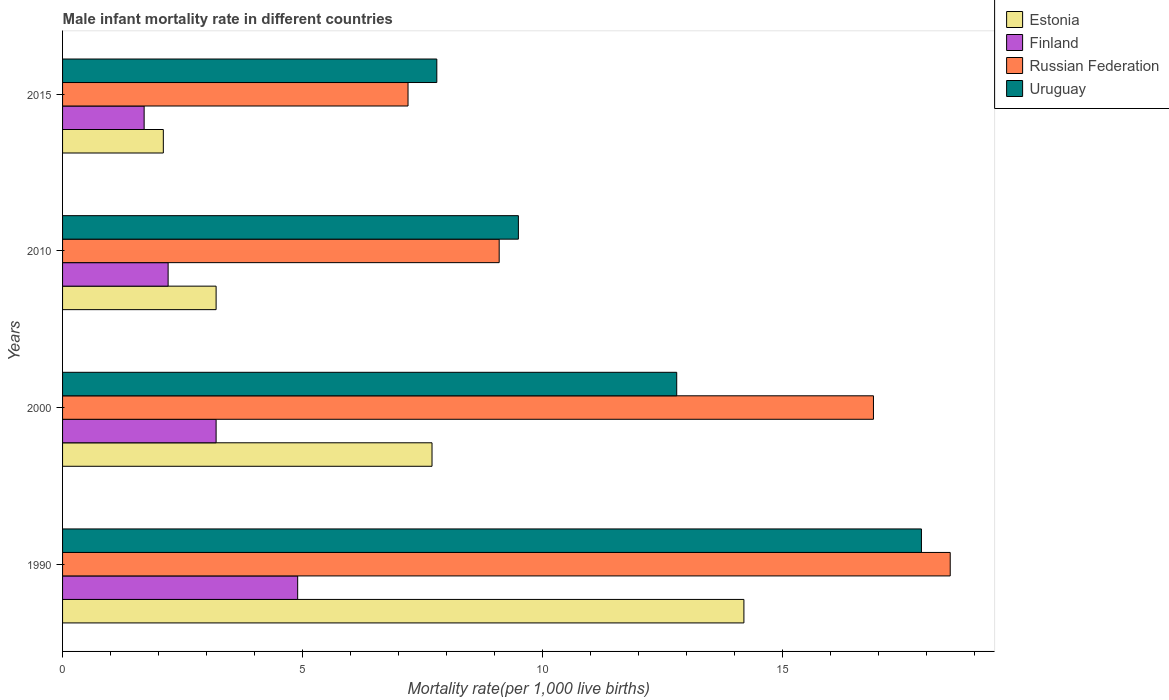How many bars are there on the 2nd tick from the top?
Offer a terse response. 4. What is the label of the 3rd group of bars from the top?
Make the answer very short. 2000. In which year was the male infant mortality rate in Russian Federation maximum?
Keep it short and to the point. 1990. In which year was the male infant mortality rate in Finland minimum?
Ensure brevity in your answer.  2015. What is the total male infant mortality rate in Estonia in the graph?
Your answer should be very brief. 27.2. What is the difference between the male infant mortality rate in Finland in 2010 and that in 2015?
Ensure brevity in your answer.  0.5. What is the difference between the male infant mortality rate in Finland in 1990 and the male infant mortality rate in Uruguay in 2010?
Give a very brief answer. -4.6. In the year 2000, what is the difference between the male infant mortality rate in Uruguay and male infant mortality rate in Russian Federation?
Ensure brevity in your answer.  -4.1. In how many years, is the male infant mortality rate in Uruguay greater than 16 ?
Give a very brief answer. 1. What is the ratio of the male infant mortality rate in Uruguay in 1990 to that in 2010?
Provide a short and direct response. 1.88. Is the male infant mortality rate in Estonia in 1990 less than that in 2015?
Your response must be concise. No. What is the difference between the highest and the second highest male infant mortality rate in Estonia?
Your response must be concise. 6.5. What is the difference between the highest and the lowest male infant mortality rate in Uruguay?
Give a very brief answer. 10.1. Is it the case that in every year, the sum of the male infant mortality rate in Finland and male infant mortality rate in Uruguay is greater than the sum of male infant mortality rate in Russian Federation and male infant mortality rate in Estonia?
Your answer should be very brief. No. What does the 3rd bar from the top in 2015 represents?
Your answer should be very brief. Finland. What does the 4th bar from the bottom in 2015 represents?
Make the answer very short. Uruguay. Is it the case that in every year, the sum of the male infant mortality rate in Finland and male infant mortality rate in Estonia is greater than the male infant mortality rate in Russian Federation?
Provide a short and direct response. No. How many legend labels are there?
Make the answer very short. 4. What is the title of the graph?
Give a very brief answer. Male infant mortality rate in different countries. Does "Ethiopia" appear as one of the legend labels in the graph?
Your answer should be compact. No. What is the label or title of the X-axis?
Your response must be concise. Mortality rate(per 1,0 live births). What is the Mortality rate(per 1,000 live births) of Estonia in 1990?
Give a very brief answer. 14.2. What is the Mortality rate(per 1,000 live births) of Uruguay in 1990?
Your answer should be compact. 17.9. What is the Mortality rate(per 1,000 live births) in Estonia in 2000?
Your response must be concise. 7.7. What is the Mortality rate(per 1,000 live births) in Estonia in 2010?
Keep it short and to the point. 3.2. What is the Mortality rate(per 1,000 live births) of Finland in 2010?
Ensure brevity in your answer.  2.2. What is the Mortality rate(per 1,000 live births) in Uruguay in 2010?
Keep it short and to the point. 9.5. What is the Mortality rate(per 1,000 live births) of Finland in 2015?
Keep it short and to the point. 1.7. What is the Mortality rate(per 1,000 live births) of Russian Federation in 2015?
Offer a terse response. 7.2. What is the Mortality rate(per 1,000 live births) in Uruguay in 2015?
Provide a short and direct response. 7.8. Across all years, what is the maximum Mortality rate(per 1,000 live births) of Finland?
Your response must be concise. 4.9. Across all years, what is the minimum Mortality rate(per 1,000 live births) in Finland?
Provide a short and direct response. 1.7. Across all years, what is the minimum Mortality rate(per 1,000 live births) in Russian Federation?
Offer a terse response. 7.2. What is the total Mortality rate(per 1,000 live births) of Estonia in the graph?
Offer a terse response. 27.2. What is the total Mortality rate(per 1,000 live births) of Finland in the graph?
Keep it short and to the point. 12. What is the total Mortality rate(per 1,000 live births) of Russian Federation in the graph?
Give a very brief answer. 51.7. What is the difference between the Mortality rate(per 1,000 live births) of Finland in 1990 and that in 2000?
Give a very brief answer. 1.7. What is the difference between the Mortality rate(per 1,000 live births) of Russian Federation in 1990 and that in 2000?
Give a very brief answer. 1.6. What is the difference between the Mortality rate(per 1,000 live births) of Uruguay in 1990 and that in 2010?
Offer a very short reply. 8.4. What is the difference between the Mortality rate(per 1,000 live births) of Estonia in 1990 and that in 2015?
Keep it short and to the point. 12.1. What is the difference between the Mortality rate(per 1,000 live births) in Uruguay in 1990 and that in 2015?
Your answer should be very brief. 10.1. What is the difference between the Mortality rate(per 1,000 live births) in Estonia in 2000 and that in 2010?
Make the answer very short. 4.5. What is the difference between the Mortality rate(per 1,000 live births) in Finland in 2000 and that in 2010?
Provide a succinct answer. 1. What is the difference between the Mortality rate(per 1,000 live births) of Finland in 2000 and that in 2015?
Provide a short and direct response. 1.5. What is the difference between the Mortality rate(per 1,000 live births) of Uruguay in 2000 and that in 2015?
Your answer should be very brief. 5. What is the difference between the Mortality rate(per 1,000 live births) in Estonia in 1990 and the Mortality rate(per 1,000 live births) in Finland in 2000?
Offer a very short reply. 11. What is the difference between the Mortality rate(per 1,000 live births) in Estonia in 1990 and the Mortality rate(per 1,000 live births) in Russian Federation in 2000?
Keep it short and to the point. -2.7. What is the difference between the Mortality rate(per 1,000 live births) in Finland in 1990 and the Mortality rate(per 1,000 live births) in Russian Federation in 2000?
Provide a short and direct response. -12. What is the difference between the Mortality rate(per 1,000 live births) in Estonia in 1990 and the Mortality rate(per 1,000 live births) in Finland in 2010?
Provide a succinct answer. 12. What is the difference between the Mortality rate(per 1,000 live births) in Estonia in 1990 and the Mortality rate(per 1,000 live births) in Uruguay in 2010?
Offer a very short reply. 4.7. What is the difference between the Mortality rate(per 1,000 live births) in Finland in 1990 and the Mortality rate(per 1,000 live births) in Russian Federation in 2010?
Keep it short and to the point. -4.2. What is the difference between the Mortality rate(per 1,000 live births) of Estonia in 1990 and the Mortality rate(per 1,000 live births) of Finland in 2015?
Your answer should be very brief. 12.5. What is the difference between the Mortality rate(per 1,000 live births) in Estonia in 1990 and the Mortality rate(per 1,000 live births) in Russian Federation in 2015?
Keep it short and to the point. 7. What is the difference between the Mortality rate(per 1,000 live births) of Estonia in 1990 and the Mortality rate(per 1,000 live births) of Uruguay in 2015?
Offer a very short reply. 6.4. What is the difference between the Mortality rate(per 1,000 live births) in Finland in 1990 and the Mortality rate(per 1,000 live births) in Russian Federation in 2015?
Your answer should be very brief. -2.3. What is the difference between the Mortality rate(per 1,000 live births) of Estonia in 2000 and the Mortality rate(per 1,000 live births) of Russian Federation in 2010?
Provide a short and direct response. -1.4. What is the difference between the Mortality rate(per 1,000 live births) of Finland in 2000 and the Mortality rate(per 1,000 live births) of Russian Federation in 2010?
Provide a short and direct response. -5.9. What is the difference between the Mortality rate(per 1,000 live births) in Finland in 2000 and the Mortality rate(per 1,000 live births) in Uruguay in 2010?
Provide a succinct answer. -6.3. What is the difference between the Mortality rate(per 1,000 live births) in Russian Federation in 2000 and the Mortality rate(per 1,000 live births) in Uruguay in 2010?
Offer a very short reply. 7.4. What is the difference between the Mortality rate(per 1,000 live births) of Estonia in 2000 and the Mortality rate(per 1,000 live births) of Finland in 2015?
Your answer should be compact. 6. What is the difference between the Mortality rate(per 1,000 live births) in Estonia in 2000 and the Mortality rate(per 1,000 live births) in Russian Federation in 2015?
Your answer should be compact. 0.5. What is the difference between the Mortality rate(per 1,000 live births) in Finland in 2000 and the Mortality rate(per 1,000 live births) in Russian Federation in 2015?
Provide a succinct answer. -4. What is the difference between the Mortality rate(per 1,000 live births) in Finland in 2000 and the Mortality rate(per 1,000 live births) in Uruguay in 2015?
Ensure brevity in your answer.  -4.6. What is the difference between the Mortality rate(per 1,000 live births) of Russian Federation in 2000 and the Mortality rate(per 1,000 live births) of Uruguay in 2015?
Provide a short and direct response. 9.1. What is the difference between the Mortality rate(per 1,000 live births) in Estonia in 2010 and the Mortality rate(per 1,000 live births) in Finland in 2015?
Keep it short and to the point. 1.5. What is the difference between the Mortality rate(per 1,000 live births) of Estonia in 2010 and the Mortality rate(per 1,000 live births) of Russian Federation in 2015?
Provide a succinct answer. -4. What is the difference between the Mortality rate(per 1,000 live births) of Finland in 2010 and the Mortality rate(per 1,000 live births) of Uruguay in 2015?
Offer a very short reply. -5.6. What is the difference between the Mortality rate(per 1,000 live births) in Russian Federation in 2010 and the Mortality rate(per 1,000 live births) in Uruguay in 2015?
Provide a succinct answer. 1.3. What is the average Mortality rate(per 1,000 live births) of Estonia per year?
Give a very brief answer. 6.8. What is the average Mortality rate(per 1,000 live births) of Russian Federation per year?
Your response must be concise. 12.93. What is the average Mortality rate(per 1,000 live births) in Uruguay per year?
Offer a very short reply. 12. In the year 1990, what is the difference between the Mortality rate(per 1,000 live births) in Estonia and Mortality rate(per 1,000 live births) in Uruguay?
Keep it short and to the point. -3.7. In the year 2000, what is the difference between the Mortality rate(per 1,000 live births) of Estonia and Mortality rate(per 1,000 live births) of Russian Federation?
Ensure brevity in your answer.  -9.2. In the year 2000, what is the difference between the Mortality rate(per 1,000 live births) of Estonia and Mortality rate(per 1,000 live births) of Uruguay?
Make the answer very short. -5.1. In the year 2000, what is the difference between the Mortality rate(per 1,000 live births) in Finland and Mortality rate(per 1,000 live births) in Russian Federation?
Make the answer very short. -13.7. In the year 2010, what is the difference between the Mortality rate(per 1,000 live births) in Estonia and Mortality rate(per 1,000 live births) in Finland?
Make the answer very short. 1. In the year 2010, what is the difference between the Mortality rate(per 1,000 live births) of Estonia and Mortality rate(per 1,000 live births) of Uruguay?
Offer a very short reply. -6.3. In the year 2010, what is the difference between the Mortality rate(per 1,000 live births) of Finland and Mortality rate(per 1,000 live births) of Uruguay?
Offer a very short reply. -7.3. In the year 2010, what is the difference between the Mortality rate(per 1,000 live births) in Russian Federation and Mortality rate(per 1,000 live births) in Uruguay?
Ensure brevity in your answer.  -0.4. In the year 2015, what is the difference between the Mortality rate(per 1,000 live births) in Estonia and Mortality rate(per 1,000 live births) in Russian Federation?
Offer a very short reply. -5.1. In the year 2015, what is the difference between the Mortality rate(per 1,000 live births) of Estonia and Mortality rate(per 1,000 live births) of Uruguay?
Your answer should be compact. -5.7. In the year 2015, what is the difference between the Mortality rate(per 1,000 live births) in Finland and Mortality rate(per 1,000 live births) in Uruguay?
Ensure brevity in your answer.  -6.1. In the year 2015, what is the difference between the Mortality rate(per 1,000 live births) in Russian Federation and Mortality rate(per 1,000 live births) in Uruguay?
Ensure brevity in your answer.  -0.6. What is the ratio of the Mortality rate(per 1,000 live births) of Estonia in 1990 to that in 2000?
Give a very brief answer. 1.84. What is the ratio of the Mortality rate(per 1,000 live births) in Finland in 1990 to that in 2000?
Offer a very short reply. 1.53. What is the ratio of the Mortality rate(per 1,000 live births) in Russian Federation in 1990 to that in 2000?
Keep it short and to the point. 1.09. What is the ratio of the Mortality rate(per 1,000 live births) of Uruguay in 1990 to that in 2000?
Make the answer very short. 1.4. What is the ratio of the Mortality rate(per 1,000 live births) of Estonia in 1990 to that in 2010?
Your answer should be very brief. 4.44. What is the ratio of the Mortality rate(per 1,000 live births) in Finland in 1990 to that in 2010?
Offer a very short reply. 2.23. What is the ratio of the Mortality rate(per 1,000 live births) of Russian Federation in 1990 to that in 2010?
Your answer should be very brief. 2.03. What is the ratio of the Mortality rate(per 1,000 live births) of Uruguay in 1990 to that in 2010?
Ensure brevity in your answer.  1.88. What is the ratio of the Mortality rate(per 1,000 live births) of Estonia in 1990 to that in 2015?
Provide a short and direct response. 6.76. What is the ratio of the Mortality rate(per 1,000 live births) in Finland in 1990 to that in 2015?
Provide a short and direct response. 2.88. What is the ratio of the Mortality rate(per 1,000 live births) in Russian Federation in 1990 to that in 2015?
Offer a very short reply. 2.57. What is the ratio of the Mortality rate(per 1,000 live births) in Uruguay in 1990 to that in 2015?
Offer a very short reply. 2.29. What is the ratio of the Mortality rate(per 1,000 live births) of Estonia in 2000 to that in 2010?
Offer a very short reply. 2.41. What is the ratio of the Mortality rate(per 1,000 live births) of Finland in 2000 to that in 2010?
Give a very brief answer. 1.45. What is the ratio of the Mortality rate(per 1,000 live births) in Russian Federation in 2000 to that in 2010?
Your answer should be very brief. 1.86. What is the ratio of the Mortality rate(per 1,000 live births) of Uruguay in 2000 to that in 2010?
Give a very brief answer. 1.35. What is the ratio of the Mortality rate(per 1,000 live births) in Estonia in 2000 to that in 2015?
Your answer should be compact. 3.67. What is the ratio of the Mortality rate(per 1,000 live births) in Finland in 2000 to that in 2015?
Your response must be concise. 1.88. What is the ratio of the Mortality rate(per 1,000 live births) in Russian Federation in 2000 to that in 2015?
Your answer should be compact. 2.35. What is the ratio of the Mortality rate(per 1,000 live births) of Uruguay in 2000 to that in 2015?
Ensure brevity in your answer.  1.64. What is the ratio of the Mortality rate(per 1,000 live births) in Estonia in 2010 to that in 2015?
Give a very brief answer. 1.52. What is the ratio of the Mortality rate(per 1,000 live births) of Finland in 2010 to that in 2015?
Ensure brevity in your answer.  1.29. What is the ratio of the Mortality rate(per 1,000 live births) in Russian Federation in 2010 to that in 2015?
Offer a very short reply. 1.26. What is the ratio of the Mortality rate(per 1,000 live births) in Uruguay in 2010 to that in 2015?
Provide a short and direct response. 1.22. What is the difference between the highest and the second highest Mortality rate(per 1,000 live births) in Russian Federation?
Keep it short and to the point. 1.6. What is the difference between the highest and the lowest Mortality rate(per 1,000 live births) in Estonia?
Provide a succinct answer. 12.1. What is the difference between the highest and the lowest Mortality rate(per 1,000 live births) in Finland?
Offer a terse response. 3.2. What is the difference between the highest and the lowest Mortality rate(per 1,000 live births) of Russian Federation?
Your answer should be very brief. 11.3. What is the difference between the highest and the lowest Mortality rate(per 1,000 live births) in Uruguay?
Offer a very short reply. 10.1. 